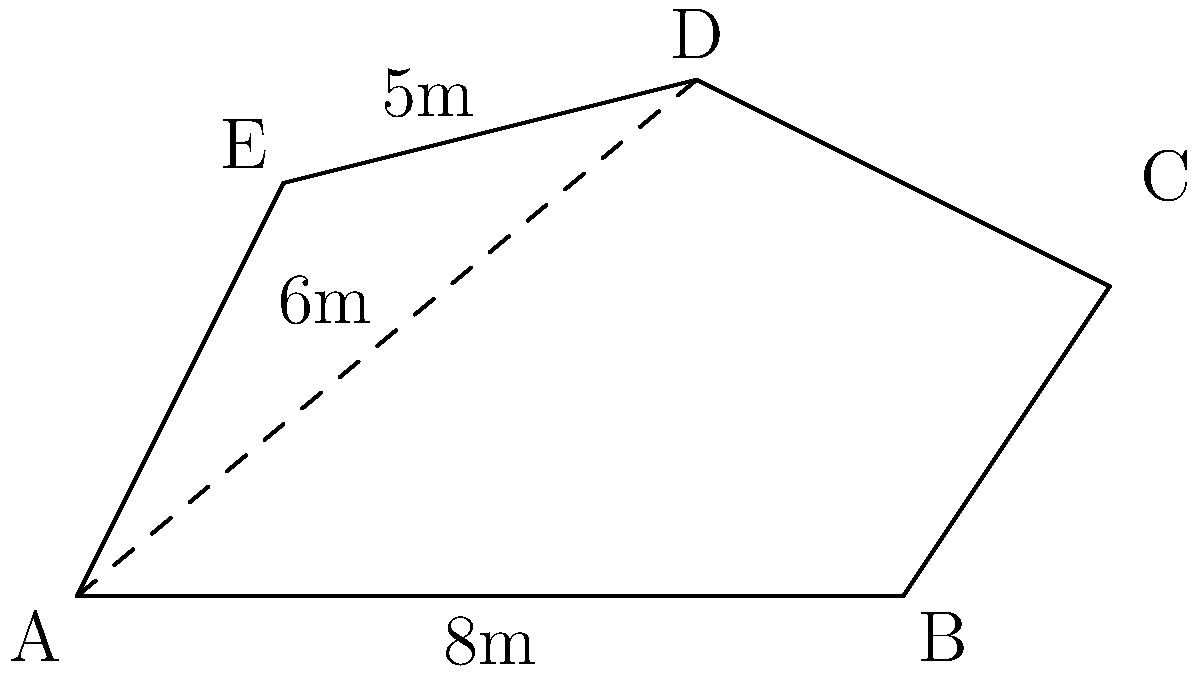A defensive position needs to be covered with a camouflage net. The position has an irregular pentagonal shape ABCDE as shown in the diagram. Given that AB = 8m, DE = 5m, and AD = 6m, calculate the area of the camouflage net needed to cover this position. Round your answer to the nearest square meter. To calculate the area of the irregular pentagon, we can divide it into three triangles: ABD, BCD, and ADE. We'll calculate the area of each triangle and sum them up.

1. For triangle ABD:
   We know AB = 8m and AD = 6m. We can find the height of this triangle using the Pythagorean theorem.
   $$h^2 + 4^2 = 6^2$$
   $$h^2 = 36 - 16 = 20$$
   $$h = \sqrt{20} \approx 4.47m$$
   Area of ABD = $\frac{1}{2} * 8 * 4.47 = 17.88m^2$

2. For triangle BCD:
   We don't have enough information to calculate this directly, but we can estimate it as approximately half of a rectangle with base 2m and height 3m.
   Estimated area of BCD = $\frac{1}{2} * 2 * 3 = 3m^2$

3. For triangle ADE:
   We know DE = 5m and AD = 6m. The base (AE) is approximately 2m.
   Area of ADE = $\frac{1}{2} * 2 * 5 = 5m^2$

4. Total area:
   $17.88 + 3 + 5 = 25.88m^2$

Rounding to the nearest square meter, we get 26m².
Answer: 26m² 